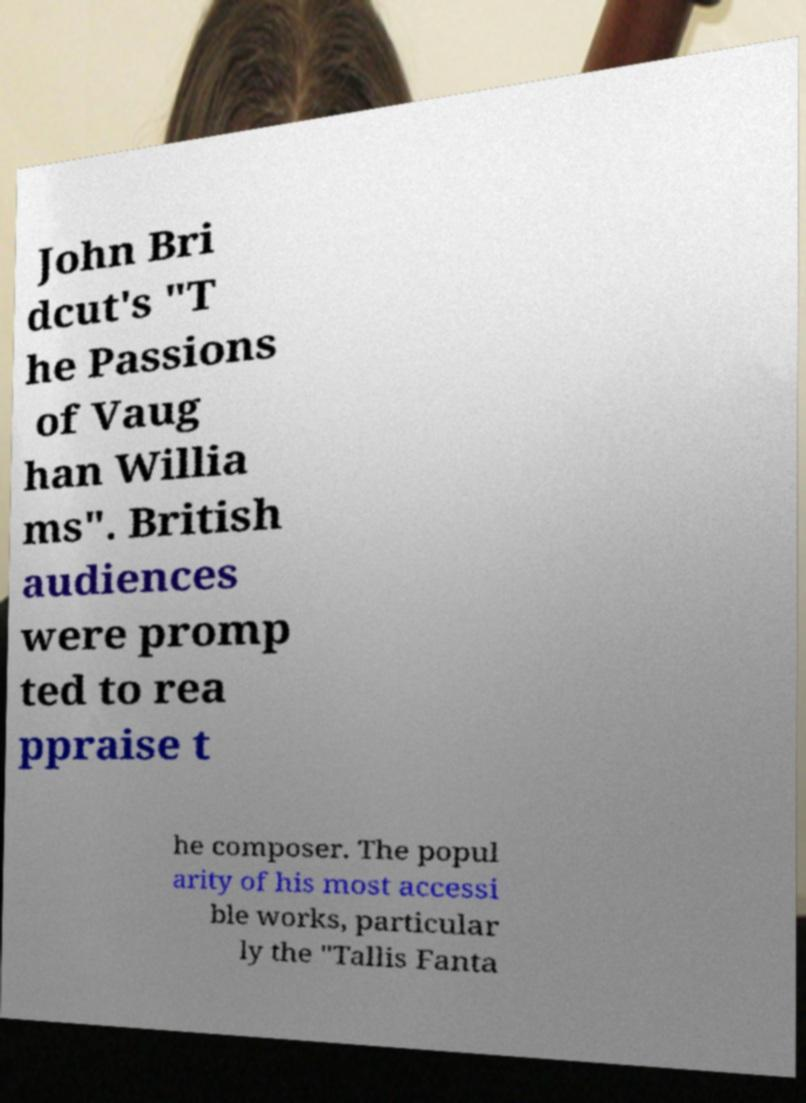Can you read and provide the text displayed in the image?This photo seems to have some interesting text. Can you extract and type it out for me? John Bri dcut's "T he Passions of Vaug han Willia ms". British audiences were promp ted to rea ppraise t he composer. The popul arity of his most accessi ble works, particular ly the "Tallis Fanta 